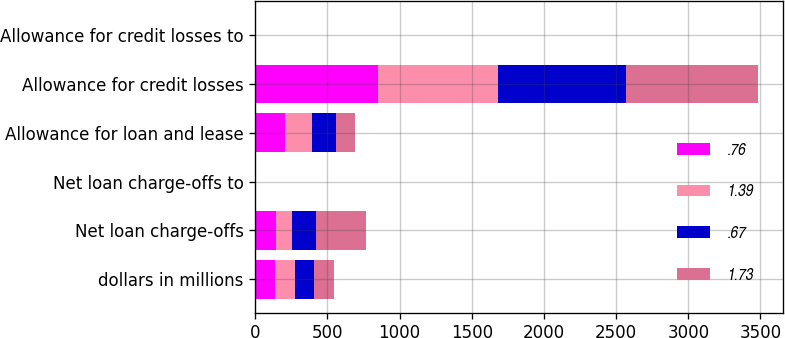<chart> <loc_0><loc_0><loc_500><loc_500><stacked_bar_chart><ecel><fcel>dollars in millions<fcel>Net loan charge-offs<fcel>Net loan charge-offs to<fcel>Allowance for loan and lease<fcel>Allowance for credit losses<fcel>Allowance for credit losses to<nl><fcel>0.76<fcel>136.9<fcel>142<fcel>0.24<fcel>205.7<fcel>852<fcel>1.42<nl><fcel>1.39<fcel>136.9<fcel>113<fcel>0.2<fcel>190<fcel>829<fcel>1.44<nl><fcel>0.67<fcel>136.9<fcel>168<fcel>0.32<fcel>166.9<fcel>885<fcel>1.63<nl><fcel>1.73<fcel>136.9<fcel>345<fcel>0.69<fcel>131.8<fcel>917<fcel>1.74<nl></chart> 